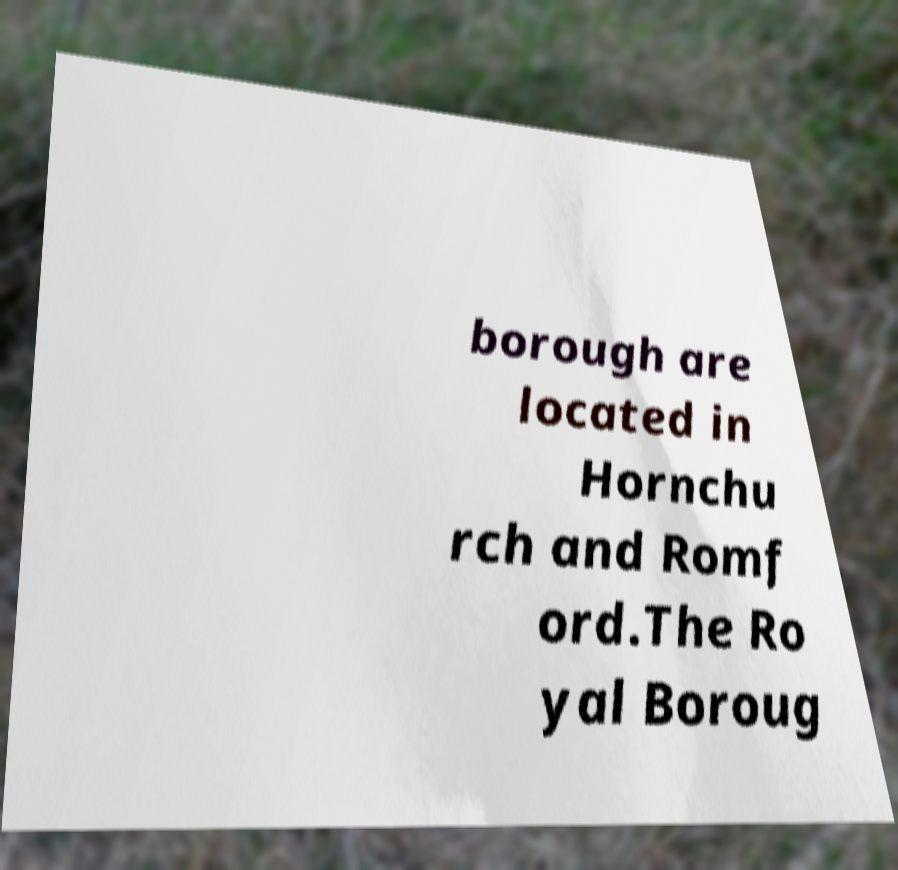Please identify and transcribe the text found in this image. borough are located in Hornchu rch and Romf ord.The Ro yal Boroug 